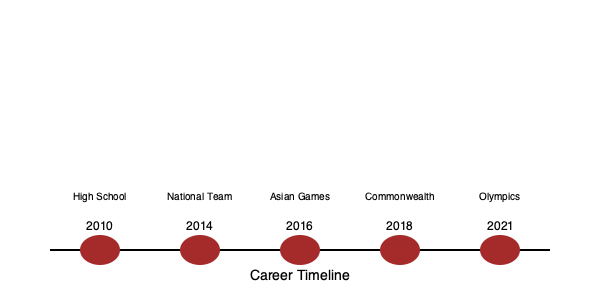In which year did Dilini Kanchana first represent Sri Lanka in a major international multi-sport event, as shown in the timeline? To answer this question, let's analyze Dilini Kanchana's career progression timeline:

1. 2010: High School - This marks the beginning of her rugby career, but it's not an international multi-sport event.
2. 2014: National Team - This indicates her first representation of Sri Lanka, but it's not specified as a multi-sport event.
3. 2016: Asian Games - This is the first major international multi-sport event mentioned in the timeline.
4. 2018: Commonwealth Games - Another major international multi-sport event, but it comes after the Asian Games.
5. 2021: Olympics - The most recent and prestigious multi-sport event, but not the first one in her career.

The Asian Games in 2016 is the first major international multi-sport event mentioned in Dilini Kanchana's career timeline. Therefore, 2016 is the correct answer to this question.
Answer: 2016 